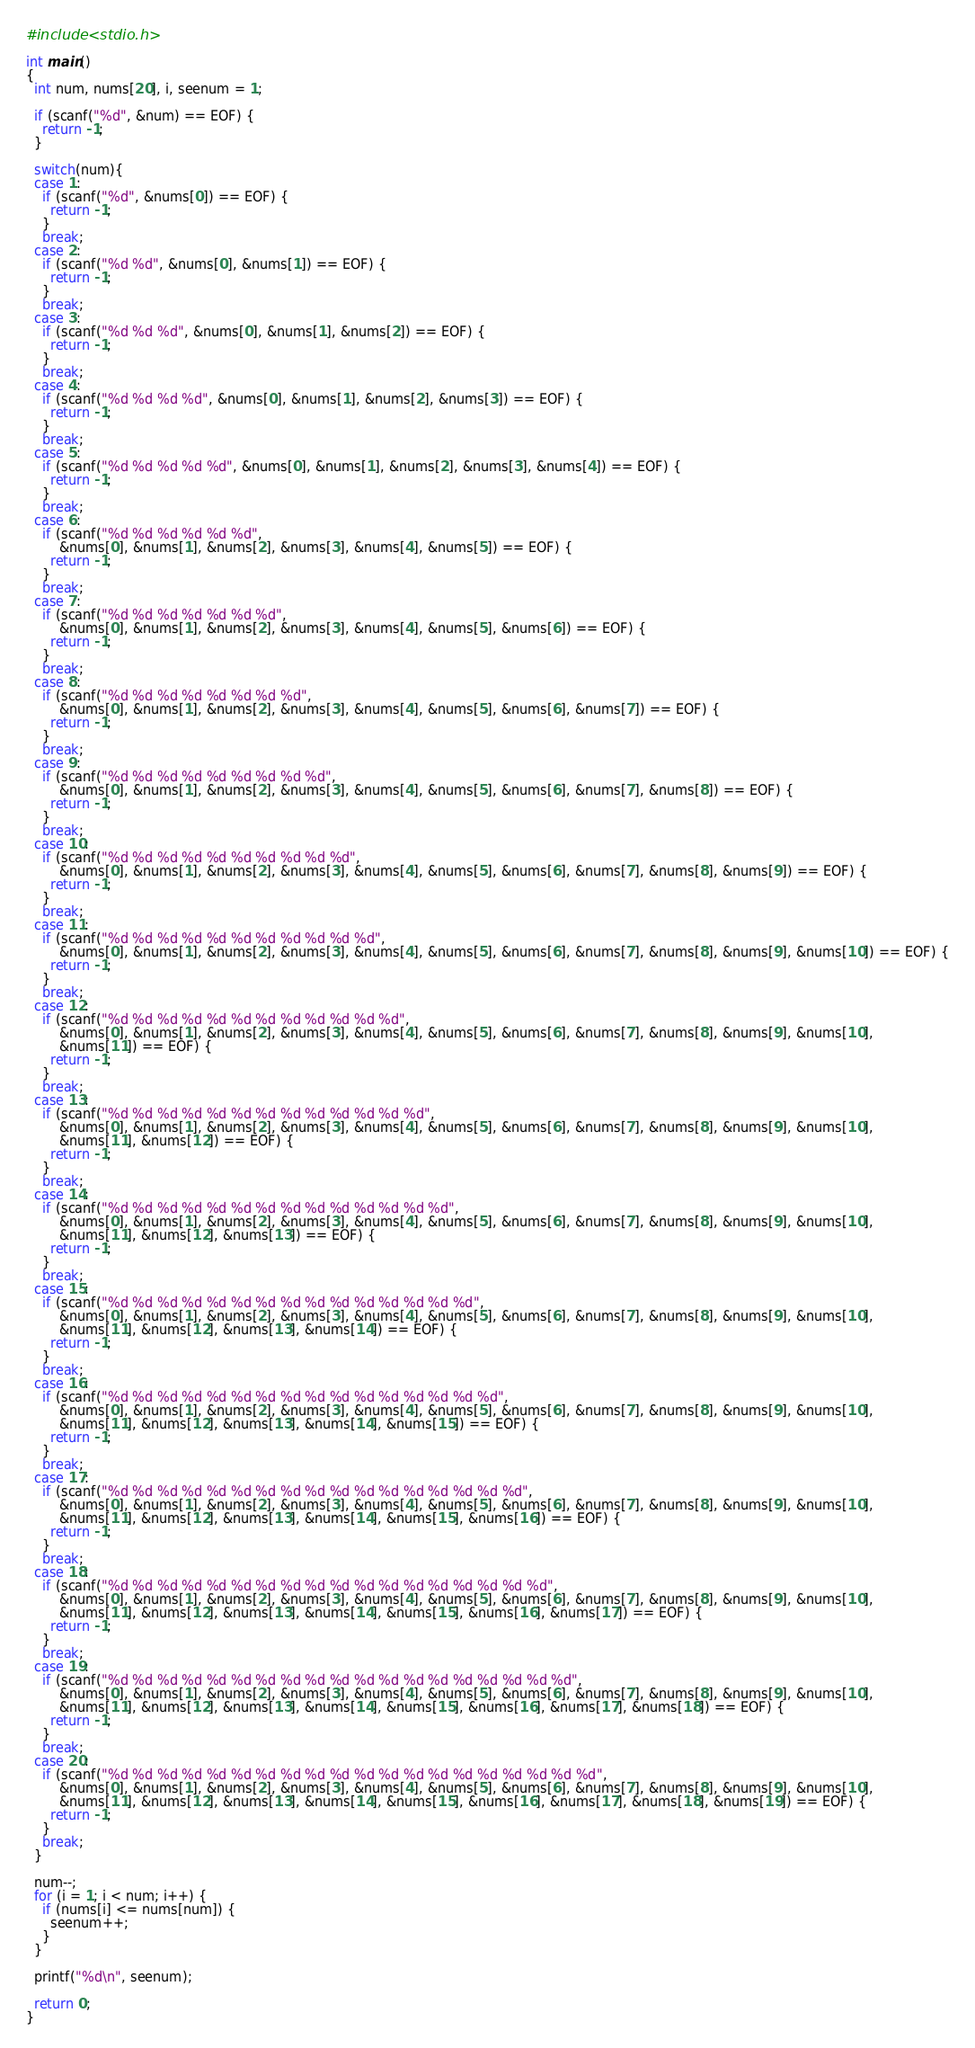Convert code to text. <code><loc_0><loc_0><loc_500><loc_500><_C_>#include <stdio.h>

int main()
{
  int num, nums[20], i, seenum = 1;

  if (scanf("%d", &num) == EOF) {
    return -1;
  }

  switch(num){
  case 1:
    if (scanf("%d", &nums[0]) == EOF) {
      return -1;
    }
    break;
  case 2:
    if (scanf("%d %d", &nums[0], &nums[1]) == EOF) {
      return -1;
    }
    break;
  case 3:
    if (scanf("%d %d %d", &nums[0], &nums[1], &nums[2]) == EOF) {
      return -1;
    }
    break;
  case 4:
    if (scanf("%d %d %d %d", &nums[0], &nums[1], &nums[2], &nums[3]) == EOF) {
      return -1;
    }
    break;
  case 5:
    if (scanf("%d %d %d %d %d", &nums[0], &nums[1], &nums[2], &nums[3], &nums[4]) == EOF) {
      return -1;
    }
    break;
  case 6:
    if (scanf("%d %d %d %d %d %d",
        &nums[0], &nums[1], &nums[2], &nums[3], &nums[4], &nums[5]) == EOF) {
      return -1;
    }
    break;
  case 7:
    if (scanf("%d %d %d %d %d %d %d",
        &nums[0], &nums[1], &nums[2], &nums[3], &nums[4], &nums[5], &nums[6]) == EOF) {
      return -1;
    }
    break;
  case 8:
    if (scanf("%d %d %d %d %d %d %d %d",
        &nums[0], &nums[1], &nums[2], &nums[3], &nums[4], &nums[5], &nums[6], &nums[7]) == EOF) {
      return -1;
    }
    break;
  case 9:
    if (scanf("%d %d %d %d %d %d %d %d %d",
        &nums[0], &nums[1], &nums[2], &nums[3], &nums[4], &nums[5], &nums[6], &nums[7], &nums[8]) == EOF) {
      return -1;
    }
    break;
  case 10:
    if (scanf("%d %d %d %d %d %d %d %d %d %d",
        &nums[0], &nums[1], &nums[2], &nums[3], &nums[4], &nums[5], &nums[6], &nums[7], &nums[8], &nums[9]) == EOF) {
      return -1;
    }
    break;
  case 11:
    if (scanf("%d %d %d %d %d %d %d %d %d %d %d",
        &nums[0], &nums[1], &nums[2], &nums[3], &nums[4], &nums[5], &nums[6], &nums[7], &nums[8], &nums[9], &nums[10]) == EOF) {
      return -1;
    }
    break;
  case 12:
    if (scanf("%d %d %d %d %d %d %d %d %d %d %d %d",
        &nums[0], &nums[1], &nums[2], &nums[3], &nums[4], &nums[5], &nums[6], &nums[7], &nums[8], &nums[9], &nums[10],
        &nums[11]) == EOF) {
      return -1;
    }
    break;
  case 13:
    if (scanf("%d %d %d %d %d %d %d %d %d %d %d %d %d",
        &nums[0], &nums[1], &nums[2], &nums[3], &nums[4], &nums[5], &nums[6], &nums[7], &nums[8], &nums[9], &nums[10],
        &nums[11], &nums[12]) == EOF) {
      return -1;
    }
    break;
  case 14:
    if (scanf("%d %d %d %d %d %d %d %d %d %d %d %d %d %d",
        &nums[0], &nums[1], &nums[2], &nums[3], &nums[4], &nums[5], &nums[6], &nums[7], &nums[8], &nums[9], &nums[10],
        &nums[11], &nums[12], &nums[13]) == EOF) {
      return -1;
    }
    break;
  case 15:
    if (scanf("%d %d %d %d %d %d %d %d %d %d %d %d %d %d %d",
        &nums[0], &nums[1], &nums[2], &nums[3], &nums[4], &nums[5], &nums[6], &nums[7], &nums[8], &nums[9], &nums[10],
        &nums[11], &nums[12], &nums[13], &nums[14]) == EOF) {
      return -1;
    }
    break;
  case 16:
    if (scanf("%d %d %d %d %d %d %d %d %d %d %d %d %d %d %d %d",
        &nums[0], &nums[1], &nums[2], &nums[3], &nums[4], &nums[5], &nums[6], &nums[7], &nums[8], &nums[9], &nums[10],
        &nums[11], &nums[12], &nums[13], &nums[14], &nums[15]) == EOF) {
      return -1;
    }
    break;
  case 17:
    if (scanf("%d %d %d %d %d %d %d %d %d %d %d %d %d %d %d %d %d",
        &nums[0], &nums[1], &nums[2], &nums[3], &nums[4], &nums[5], &nums[6], &nums[7], &nums[8], &nums[9], &nums[10],
        &nums[11], &nums[12], &nums[13], &nums[14], &nums[15], &nums[16]) == EOF) {
      return -1;
    }
    break;
  case 18:
    if (scanf("%d %d %d %d %d %d %d %d %d %d %d %d %d %d %d %d %d %d",
        &nums[0], &nums[1], &nums[2], &nums[3], &nums[4], &nums[5], &nums[6], &nums[7], &nums[8], &nums[9], &nums[10],
        &nums[11], &nums[12], &nums[13], &nums[14], &nums[15], &nums[16], &nums[17]) == EOF) {
      return -1;
    }
    break;
  case 19:
    if (scanf("%d %d %d %d %d %d %d %d %d %d %d %d %d %d %d %d %d %d %d",
        &nums[0], &nums[1], &nums[2], &nums[3], &nums[4], &nums[5], &nums[6], &nums[7], &nums[8], &nums[9], &nums[10],
        &nums[11], &nums[12], &nums[13], &nums[14], &nums[15], &nums[16], &nums[17], &nums[18]) == EOF) {
      return -1;
    }
    break;
  case 20:
    if (scanf("%d %d %d %d %d %d %d %d %d %d %d %d %d %d %d %d %d %d %d %d",
        &nums[0], &nums[1], &nums[2], &nums[3], &nums[4], &nums[5], &nums[6], &nums[7], &nums[8], &nums[9], &nums[10],
        &nums[11], &nums[12], &nums[13], &nums[14], &nums[15], &nums[16], &nums[17], &nums[18], &nums[19]) == EOF) {
      return -1;
    }
    break;
  }
  
  num--;
  for (i = 1; i < num; i++) {
    if (nums[i] <= nums[num]) {
      seenum++;
    }
  }

  printf("%d\n", seenum);

  return 0;
}</code> 